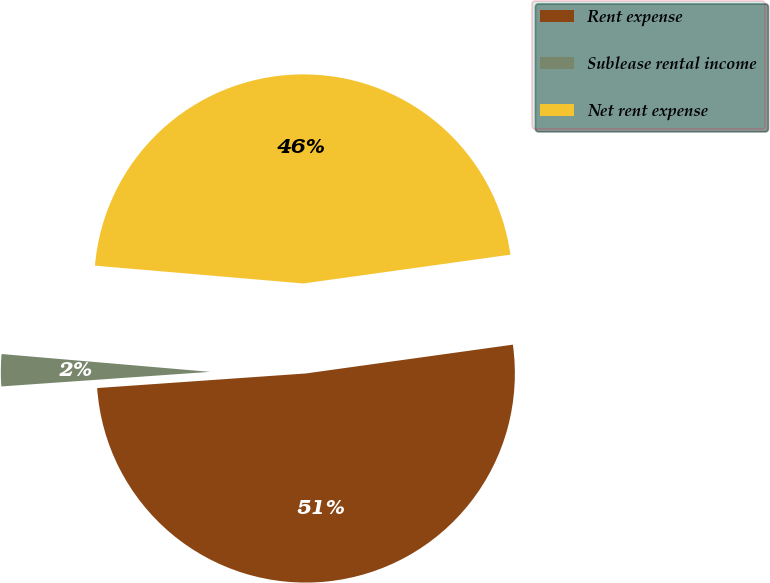<chart> <loc_0><loc_0><loc_500><loc_500><pie_chart><fcel>Rent expense<fcel>Sublease rental income<fcel>Net rent expense<nl><fcel>51.09%<fcel>2.47%<fcel>46.44%<nl></chart> 